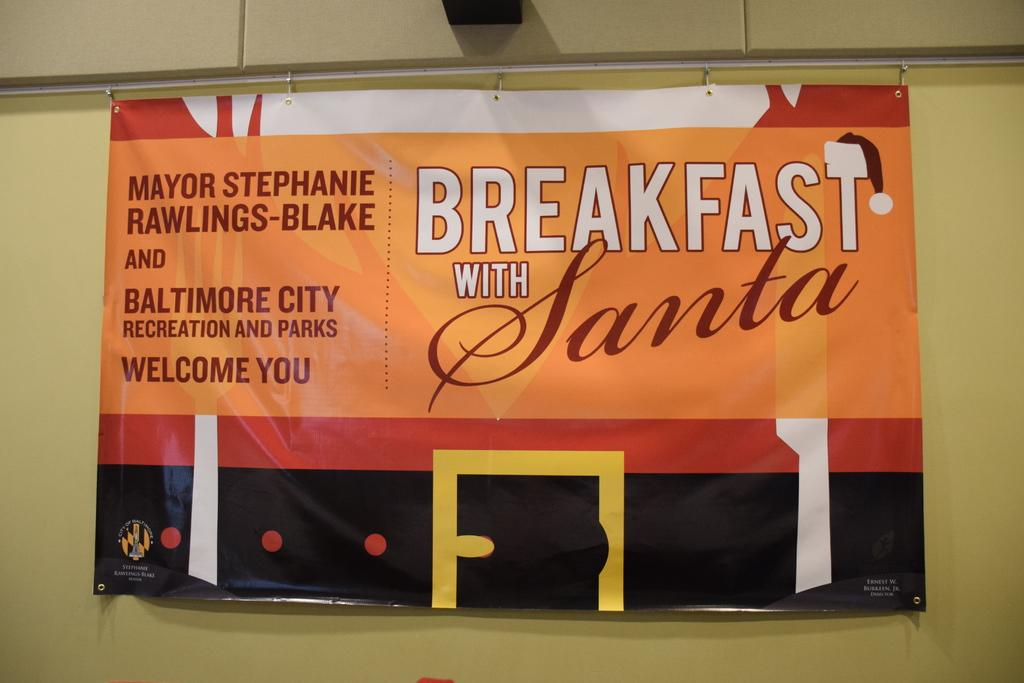Provide a one-sentence caption for the provided image. A large sign that reads breakfast with Santa is handing from an iron bar. 